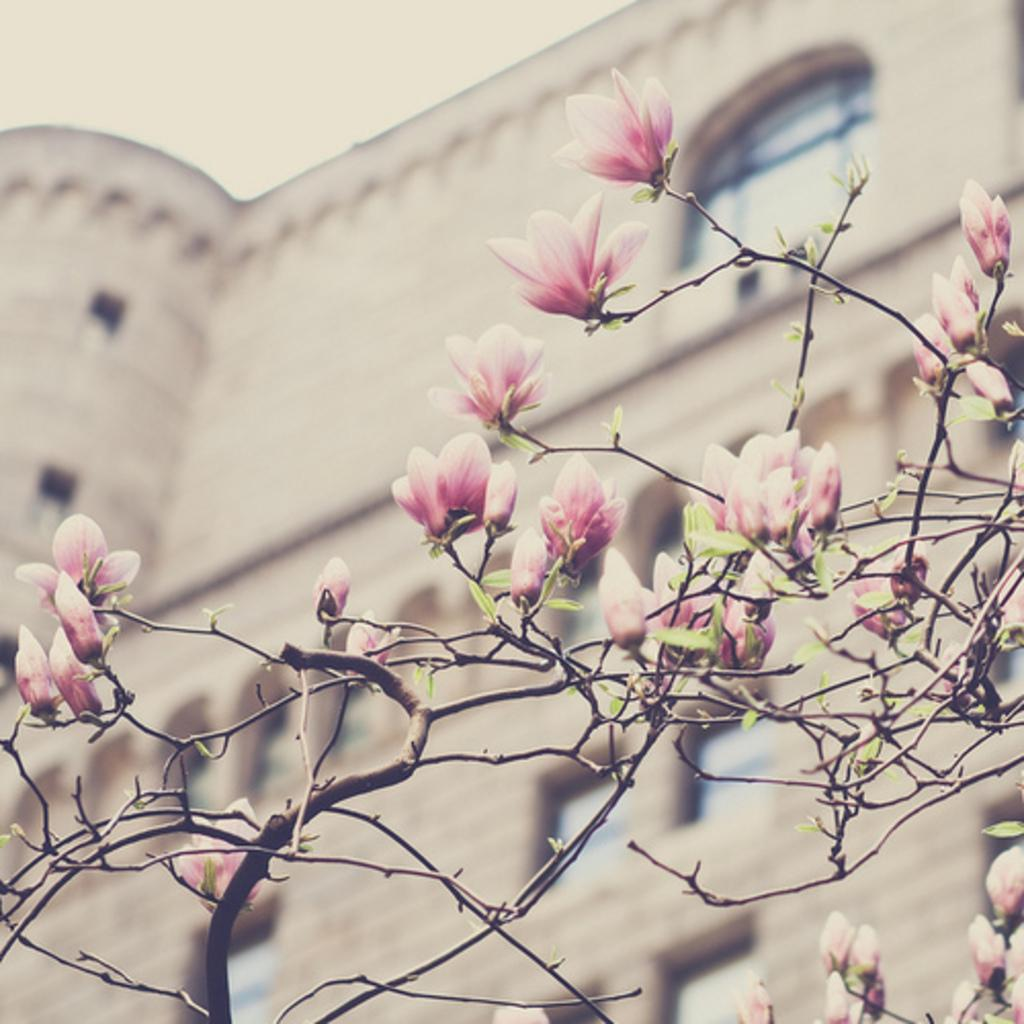What is located in the foreground of the image? There are flowers in the foreground of the image. How are the flowers connected to the ground? The flowers are attached to stems. What can be seen in the background of the image? There is a building and the sky visible in the background of the image. What type of ink can be seen dripping from the bucket in the image? There is no bucket or ink present in the image. How does the bridge connect the two sides of the image? There is no bridge present in the image; it features flowers in the foreground and a building in the background. 